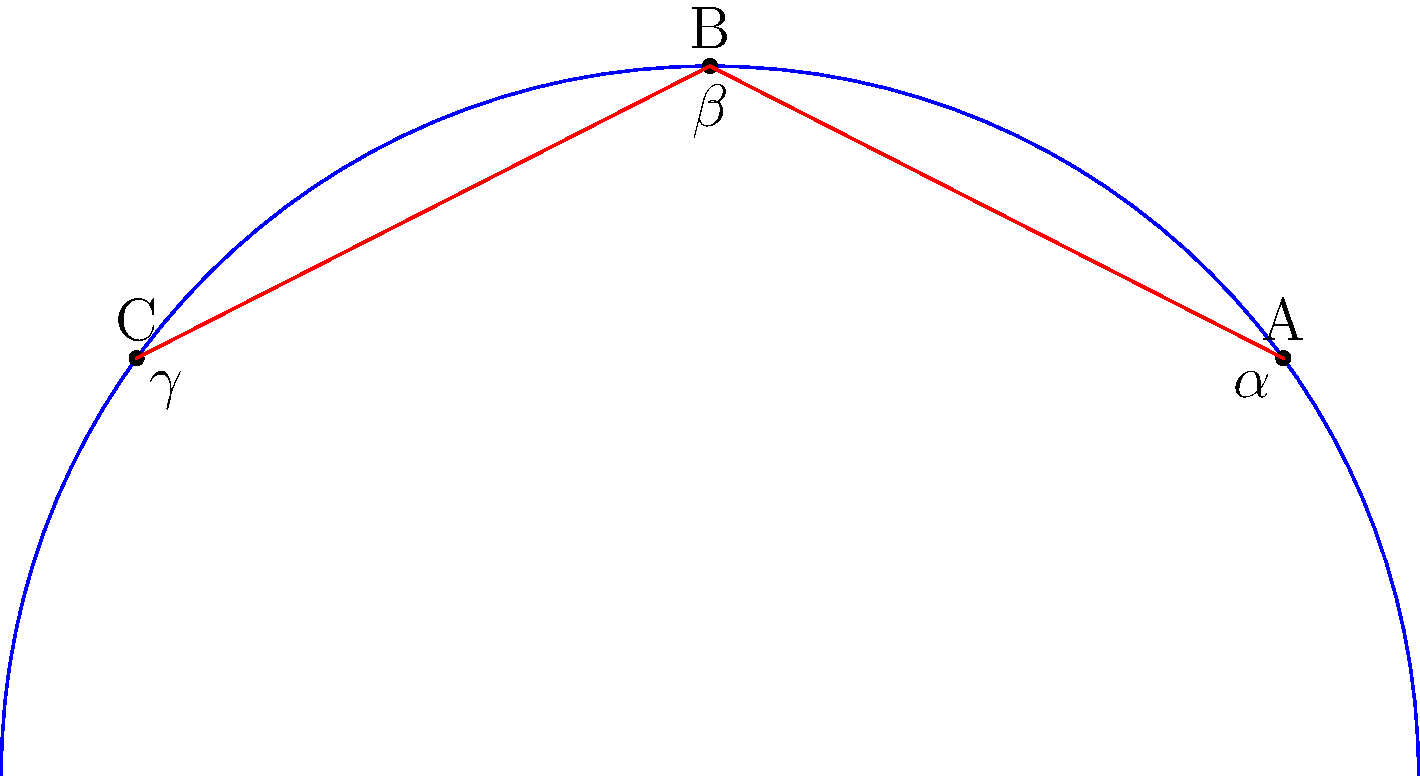In your craft beer bar, you've designed a unique curved floor plan. Three tables A, B, and C are placed along this curve as shown. Given that the central angle subtended by arc AB is 60°, and the central angle subtended by arc BC is 60°, what is the sum of the angles $\alpha$, $\beta$, and $\gamma$ formed by the straight lines connecting these tables? Let's approach this step-by-step:

1) In Euclidean geometry, the sum of angles in a triangle is always 180°. However, this is a non-Euclidean problem on a curved surface.

2) The key here is to understand that on a curved surface, the sum of angles in a triangle is greater than 180°. The excess over 180° is proportional to the area of the triangle.

3) In this case, we're dealing with a spherical surface (the curved floor plan can be thought of as part of a sphere).

4) For a spherical triangle, the sum of angles is given by the formula:
   $\alpha + \beta + \gamma = 180° + A$
   where A is the area of the triangle in steradians.

5) The area of the triangle is related to the central angles. The total central angle here is 120° (60° + 60°).

6) In radians, this is $\frac{2\pi}{3}$.

7) The area of this spherical triangle in steradians is equal to this angle, $\frac{2\pi}{3}$.

8) Converting back to degrees: $\frac{2\pi}{3} \cdot \frac{180°}{\pi} = 120°$

9) Therefore, the sum of angles in this spherical triangle is:
   $180° + 120° = 300°$

Thus, the sum of angles $\alpha$, $\beta$, and $\gamma$ is 300°.
Answer: 300° 